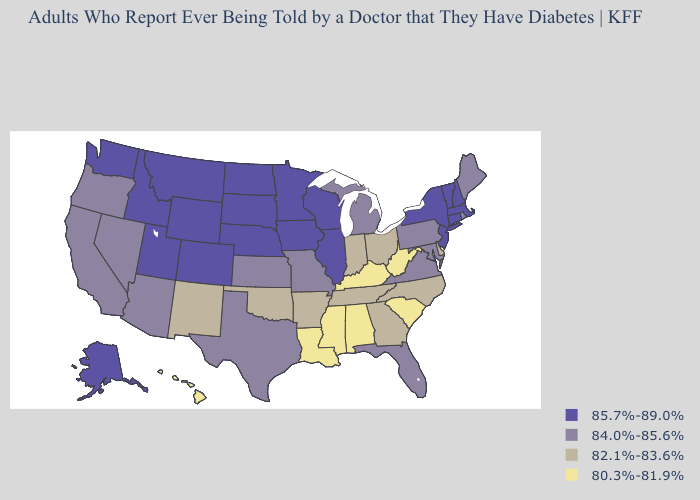Name the states that have a value in the range 84.0%-85.6%?
Answer briefly. Arizona, California, Florida, Kansas, Maine, Maryland, Michigan, Missouri, Nevada, Oregon, Pennsylvania, Rhode Island, Texas, Virginia. Name the states that have a value in the range 80.3%-81.9%?
Concise answer only. Alabama, Hawaii, Kentucky, Louisiana, Mississippi, South Carolina, West Virginia. Name the states that have a value in the range 84.0%-85.6%?
Concise answer only. Arizona, California, Florida, Kansas, Maine, Maryland, Michigan, Missouri, Nevada, Oregon, Pennsylvania, Rhode Island, Texas, Virginia. What is the value of Texas?
Be succinct. 84.0%-85.6%. What is the highest value in the USA?
Give a very brief answer. 85.7%-89.0%. Does the map have missing data?
Keep it brief. No. Which states have the highest value in the USA?
Give a very brief answer. Alaska, Colorado, Connecticut, Idaho, Illinois, Iowa, Massachusetts, Minnesota, Montana, Nebraska, New Hampshire, New Jersey, New York, North Dakota, South Dakota, Utah, Vermont, Washington, Wisconsin, Wyoming. What is the lowest value in the USA?
Write a very short answer. 80.3%-81.9%. Which states hav the highest value in the South?
Answer briefly. Florida, Maryland, Texas, Virginia. Which states have the lowest value in the MidWest?
Give a very brief answer. Indiana, Ohio. Does Washington have the lowest value in the USA?
Give a very brief answer. No. What is the value of Montana?
Answer briefly. 85.7%-89.0%. Which states have the highest value in the USA?
Give a very brief answer. Alaska, Colorado, Connecticut, Idaho, Illinois, Iowa, Massachusetts, Minnesota, Montana, Nebraska, New Hampshire, New Jersey, New York, North Dakota, South Dakota, Utah, Vermont, Washington, Wisconsin, Wyoming. Which states have the highest value in the USA?
Give a very brief answer. Alaska, Colorado, Connecticut, Idaho, Illinois, Iowa, Massachusetts, Minnesota, Montana, Nebraska, New Hampshire, New Jersey, New York, North Dakota, South Dakota, Utah, Vermont, Washington, Wisconsin, Wyoming. 